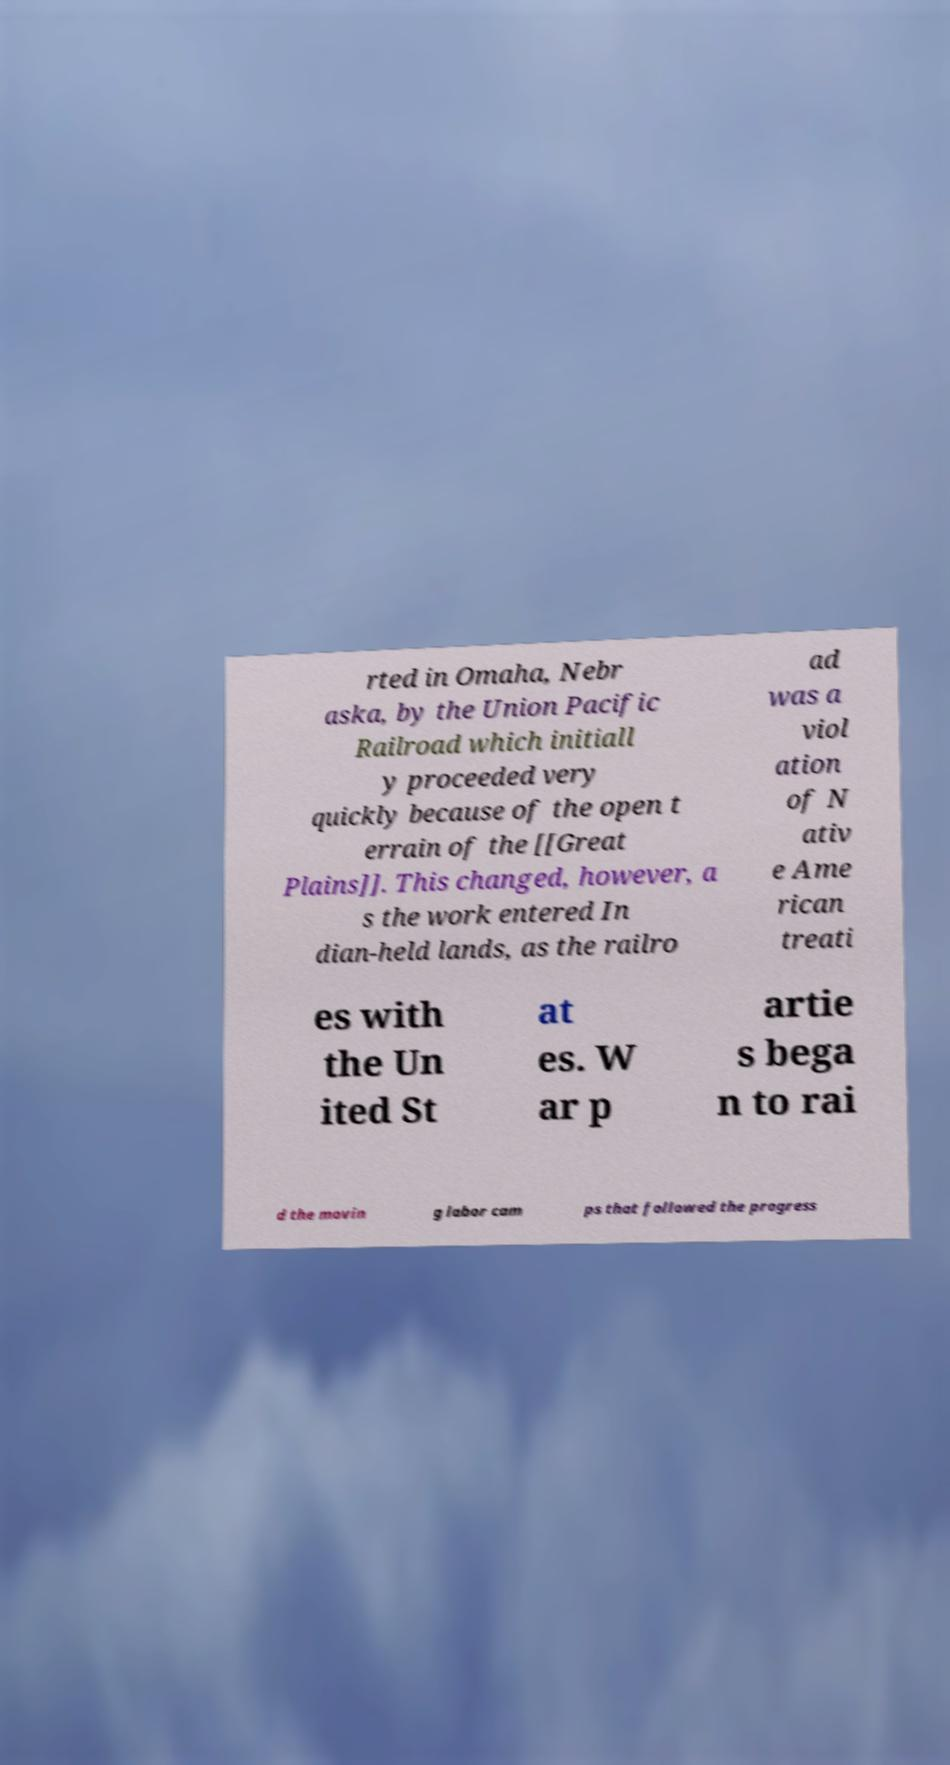Please read and relay the text visible in this image. What does it say? rted in Omaha, Nebr aska, by the Union Pacific Railroad which initiall y proceeded very quickly because of the open t errain of the [[Great Plains]]. This changed, however, a s the work entered In dian-held lands, as the railro ad was a viol ation of N ativ e Ame rican treati es with the Un ited St at es. W ar p artie s bega n to rai d the movin g labor cam ps that followed the progress 